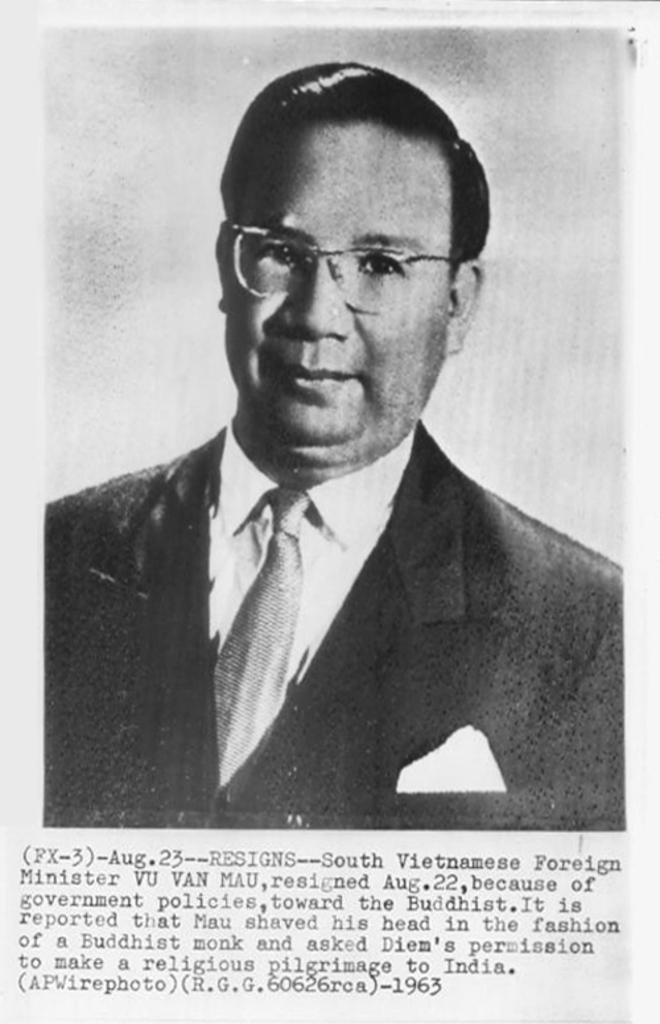Who is present in the image? There is a man in the image. What is the man wearing? The man is wearing a suit. What can be found below the image? There is text below the image. What color scheme is used in the image? The image is black and white. What type of jeans is the man wearing in the image? The man is not wearing jeans in the image; he is wearing a suit. Can you see a parcel being delivered in the image? There is no parcel or delivery depicted in the image. 